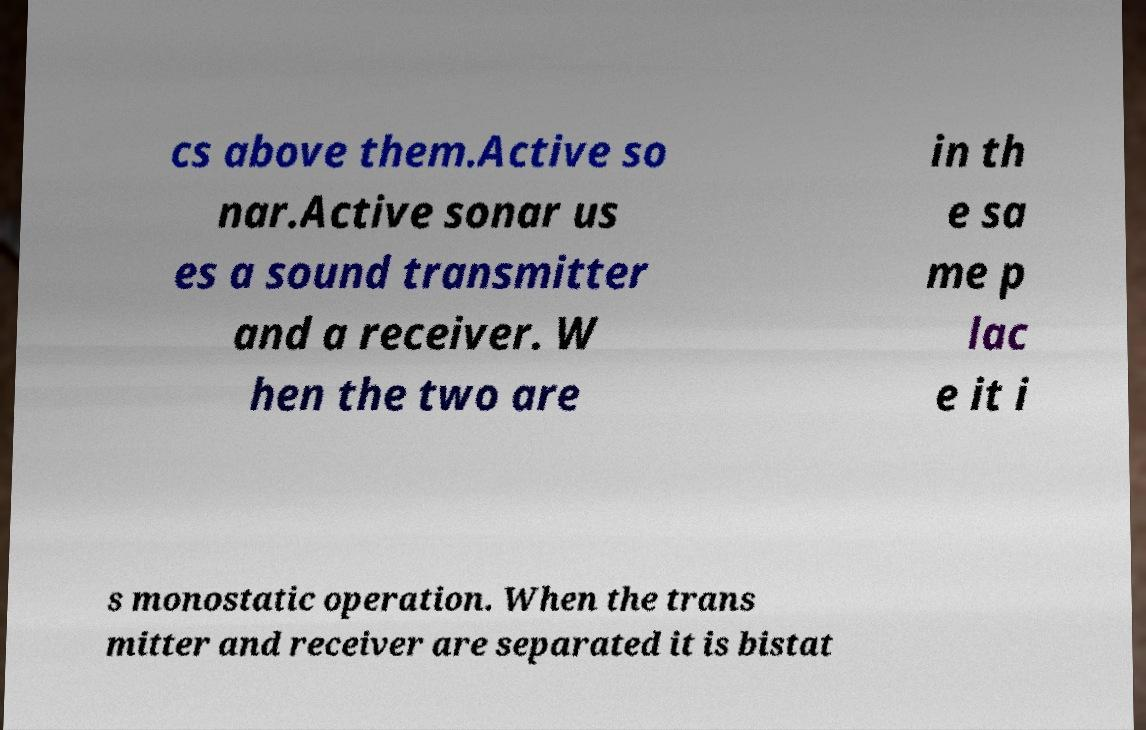Please read and relay the text visible in this image. What does it say? cs above them.Active so nar.Active sonar us es a sound transmitter and a receiver. W hen the two are in th e sa me p lac e it i s monostatic operation. When the trans mitter and receiver are separated it is bistat 